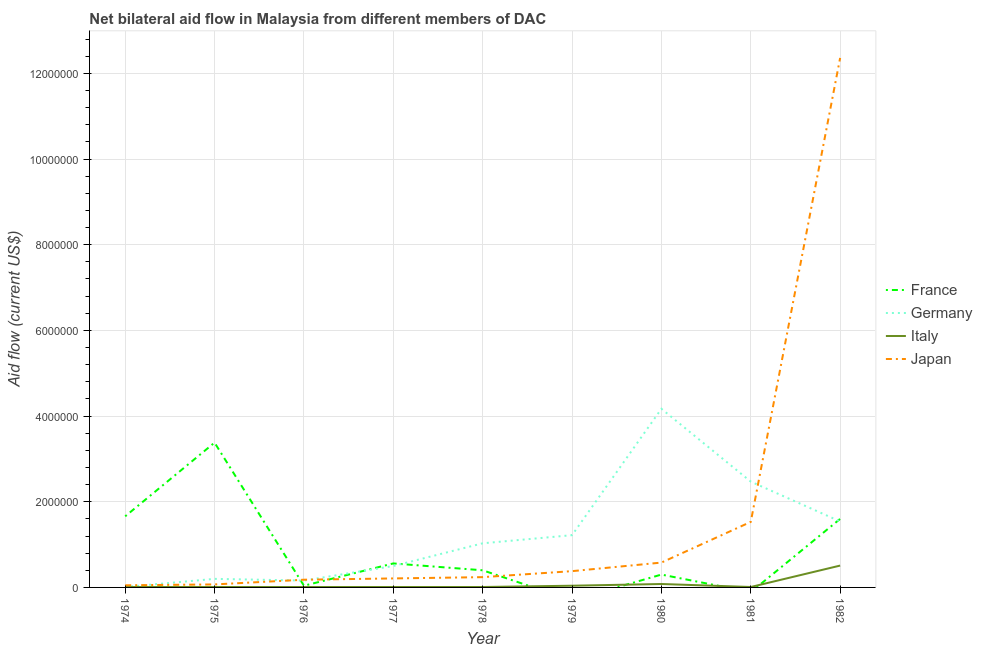How many different coloured lines are there?
Provide a succinct answer. 4. Is the number of lines equal to the number of legend labels?
Ensure brevity in your answer.  No. What is the amount of aid given by japan in 1982?
Provide a succinct answer. 1.24e+07. Across all years, what is the maximum amount of aid given by japan?
Ensure brevity in your answer.  1.24e+07. In which year was the amount of aid given by italy maximum?
Your response must be concise. 1982. What is the total amount of aid given by france in the graph?
Your answer should be compact. 7.94e+06. What is the difference between the amount of aid given by japan in 1976 and that in 1980?
Offer a terse response. -4.00e+05. What is the difference between the amount of aid given by italy in 1981 and the amount of aid given by japan in 1977?
Make the answer very short. -2.00e+05. What is the average amount of aid given by france per year?
Provide a short and direct response. 8.82e+05. In the year 1975, what is the difference between the amount of aid given by italy and amount of aid given by germany?
Provide a succinct answer. -1.90e+05. In how many years, is the amount of aid given by japan greater than 6400000 US$?
Your answer should be compact. 1. What is the ratio of the amount of aid given by italy in 1974 to that in 1979?
Offer a very short reply. 0.25. Is the difference between the amount of aid given by italy in 1976 and 1982 greater than the difference between the amount of aid given by japan in 1976 and 1982?
Ensure brevity in your answer.  Yes. What is the difference between the highest and the second highest amount of aid given by france?
Your answer should be compact. 1.72e+06. What is the difference between the highest and the lowest amount of aid given by italy?
Provide a succinct answer. 5.00e+05. Is the sum of the amount of aid given by italy in 1980 and 1981 greater than the maximum amount of aid given by japan across all years?
Offer a very short reply. No. Is it the case that in every year, the sum of the amount of aid given by japan and amount of aid given by france is greater than the sum of amount of aid given by italy and amount of aid given by germany?
Your answer should be very brief. No. Is it the case that in every year, the sum of the amount of aid given by france and amount of aid given by germany is greater than the amount of aid given by italy?
Your answer should be very brief. Yes. Does the amount of aid given by japan monotonically increase over the years?
Make the answer very short. Yes. Is the amount of aid given by france strictly less than the amount of aid given by italy over the years?
Your answer should be compact. No. How many lines are there?
Ensure brevity in your answer.  4. How many years are there in the graph?
Give a very brief answer. 9. What is the difference between two consecutive major ticks on the Y-axis?
Your answer should be compact. 2.00e+06. How many legend labels are there?
Offer a terse response. 4. How are the legend labels stacked?
Ensure brevity in your answer.  Vertical. What is the title of the graph?
Your answer should be compact. Net bilateral aid flow in Malaysia from different members of DAC. What is the label or title of the X-axis?
Provide a short and direct response. Year. What is the label or title of the Y-axis?
Provide a succinct answer. Aid flow (current US$). What is the Aid flow (current US$) in France in 1974?
Offer a terse response. 1.66e+06. What is the Aid flow (current US$) in Italy in 1974?
Keep it short and to the point. 10000. What is the Aid flow (current US$) in Japan in 1974?
Provide a short and direct response. 5.00e+04. What is the Aid flow (current US$) of France in 1975?
Your answer should be compact. 3.38e+06. What is the Aid flow (current US$) in Germany in 1975?
Keep it short and to the point. 2.00e+05. What is the Aid flow (current US$) of Japan in 1975?
Offer a very short reply. 7.00e+04. What is the Aid flow (current US$) in France in 1976?
Provide a succinct answer. 4.00e+04. What is the Aid flow (current US$) in Italy in 1976?
Your response must be concise. 10000. What is the Aid flow (current US$) in France in 1977?
Make the answer very short. 5.60e+05. What is the Aid flow (current US$) of Japan in 1977?
Give a very brief answer. 2.10e+05. What is the Aid flow (current US$) in Germany in 1978?
Make the answer very short. 1.03e+06. What is the Aid flow (current US$) of Germany in 1979?
Ensure brevity in your answer.  1.22e+06. What is the Aid flow (current US$) of Germany in 1980?
Offer a terse response. 4.17e+06. What is the Aid flow (current US$) of Italy in 1980?
Your response must be concise. 8.00e+04. What is the Aid flow (current US$) of Japan in 1980?
Offer a very short reply. 5.80e+05. What is the Aid flow (current US$) of Germany in 1981?
Keep it short and to the point. 2.47e+06. What is the Aid flow (current US$) of Italy in 1981?
Ensure brevity in your answer.  10000. What is the Aid flow (current US$) of Japan in 1981?
Make the answer very short. 1.53e+06. What is the Aid flow (current US$) of France in 1982?
Provide a succinct answer. 1.60e+06. What is the Aid flow (current US$) of Germany in 1982?
Offer a very short reply. 1.54e+06. What is the Aid flow (current US$) of Italy in 1982?
Your answer should be very brief. 5.10e+05. What is the Aid flow (current US$) of Japan in 1982?
Provide a succinct answer. 1.24e+07. Across all years, what is the maximum Aid flow (current US$) in France?
Your response must be concise. 3.38e+06. Across all years, what is the maximum Aid flow (current US$) in Germany?
Provide a short and direct response. 4.17e+06. Across all years, what is the maximum Aid flow (current US$) of Italy?
Your response must be concise. 5.10e+05. Across all years, what is the maximum Aid flow (current US$) of Japan?
Your answer should be compact. 1.24e+07. What is the total Aid flow (current US$) in France in the graph?
Provide a succinct answer. 7.94e+06. What is the total Aid flow (current US$) in Germany in the graph?
Make the answer very short. 1.13e+07. What is the total Aid flow (current US$) of Italy in the graph?
Offer a very short reply. 6.90e+05. What is the total Aid flow (current US$) of Japan in the graph?
Provide a short and direct response. 1.56e+07. What is the difference between the Aid flow (current US$) of France in 1974 and that in 1975?
Provide a short and direct response. -1.72e+06. What is the difference between the Aid flow (current US$) in Germany in 1974 and that in 1975?
Provide a succinct answer. -1.90e+05. What is the difference between the Aid flow (current US$) of Italy in 1974 and that in 1975?
Make the answer very short. 0. What is the difference between the Aid flow (current US$) in France in 1974 and that in 1976?
Your answer should be compact. 1.62e+06. What is the difference between the Aid flow (current US$) of Germany in 1974 and that in 1976?
Provide a succinct answer. -1.50e+05. What is the difference between the Aid flow (current US$) in France in 1974 and that in 1977?
Offer a terse response. 1.10e+06. What is the difference between the Aid flow (current US$) of Germany in 1974 and that in 1977?
Make the answer very short. -4.90e+05. What is the difference between the Aid flow (current US$) in Italy in 1974 and that in 1977?
Provide a short and direct response. 0. What is the difference between the Aid flow (current US$) in Japan in 1974 and that in 1977?
Make the answer very short. -1.60e+05. What is the difference between the Aid flow (current US$) in France in 1974 and that in 1978?
Your response must be concise. 1.26e+06. What is the difference between the Aid flow (current US$) in Germany in 1974 and that in 1978?
Your answer should be very brief. -1.02e+06. What is the difference between the Aid flow (current US$) of Japan in 1974 and that in 1978?
Provide a short and direct response. -1.90e+05. What is the difference between the Aid flow (current US$) of Germany in 1974 and that in 1979?
Provide a succinct answer. -1.21e+06. What is the difference between the Aid flow (current US$) in Italy in 1974 and that in 1979?
Keep it short and to the point. -3.00e+04. What is the difference between the Aid flow (current US$) of Japan in 1974 and that in 1979?
Provide a succinct answer. -3.30e+05. What is the difference between the Aid flow (current US$) of France in 1974 and that in 1980?
Offer a very short reply. 1.36e+06. What is the difference between the Aid flow (current US$) in Germany in 1974 and that in 1980?
Make the answer very short. -4.16e+06. What is the difference between the Aid flow (current US$) in Italy in 1974 and that in 1980?
Your response must be concise. -7.00e+04. What is the difference between the Aid flow (current US$) of Japan in 1974 and that in 1980?
Offer a very short reply. -5.30e+05. What is the difference between the Aid flow (current US$) of Germany in 1974 and that in 1981?
Make the answer very short. -2.46e+06. What is the difference between the Aid flow (current US$) of Italy in 1974 and that in 1981?
Your answer should be very brief. 0. What is the difference between the Aid flow (current US$) of Japan in 1974 and that in 1981?
Your response must be concise. -1.48e+06. What is the difference between the Aid flow (current US$) in France in 1974 and that in 1982?
Provide a succinct answer. 6.00e+04. What is the difference between the Aid flow (current US$) in Germany in 1974 and that in 1982?
Your response must be concise. -1.53e+06. What is the difference between the Aid flow (current US$) of Italy in 1974 and that in 1982?
Provide a succinct answer. -5.00e+05. What is the difference between the Aid flow (current US$) in Japan in 1974 and that in 1982?
Provide a short and direct response. -1.23e+07. What is the difference between the Aid flow (current US$) of France in 1975 and that in 1976?
Make the answer very short. 3.34e+06. What is the difference between the Aid flow (current US$) in Italy in 1975 and that in 1976?
Ensure brevity in your answer.  0. What is the difference between the Aid flow (current US$) of Japan in 1975 and that in 1976?
Make the answer very short. -1.10e+05. What is the difference between the Aid flow (current US$) of France in 1975 and that in 1977?
Your response must be concise. 2.82e+06. What is the difference between the Aid flow (current US$) in Germany in 1975 and that in 1977?
Provide a succinct answer. -3.00e+05. What is the difference between the Aid flow (current US$) of Italy in 1975 and that in 1977?
Make the answer very short. 0. What is the difference between the Aid flow (current US$) in France in 1975 and that in 1978?
Your response must be concise. 2.98e+06. What is the difference between the Aid flow (current US$) in Germany in 1975 and that in 1978?
Provide a succinct answer. -8.30e+05. What is the difference between the Aid flow (current US$) in Italy in 1975 and that in 1978?
Your response must be concise. 0. What is the difference between the Aid flow (current US$) of Germany in 1975 and that in 1979?
Your answer should be compact. -1.02e+06. What is the difference between the Aid flow (current US$) of Japan in 1975 and that in 1979?
Your answer should be very brief. -3.10e+05. What is the difference between the Aid flow (current US$) of France in 1975 and that in 1980?
Keep it short and to the point. 3.08e+06. What is the difference between the Aid flow (current US$) of Germany in 1975 and that in 1980?
Provide a succinct answer. -3.97e+06. What is the difference between the Aid flow (current US$) in Japan in 1975 and that in 1980?
Offer a terse response. -5.10e+05. What is the difference between the Aid flow (current US$) of Germany in 1975 and that in 1981?
Offer a very short reply. -2.27e+06. What is the difference between the Aid flow (current US$) in Italy in 1975 and that in 1981?
Provide a short and direct response. 0. What is the difference between the Aid flow (current US$) in Japan in 1975 and that in 1981?
Ensure brevity in your answer.  -1.46e+06. What is the difference between the Aid flow (current US$) of France in 1975 and that in 1982?
Give a very brief answer. 1.78e+06. What is the difference between the Aid flow (current US$) of Germany in 1975 and that in 1982?
Provide a short and direct response. -1.34e+06. What is the difference between the Aid flow (current US$) of Italy in 1975 and that in 1982?
Keep it short and to the point. -5.00e+05. What is the difference between the Aid flow (current US$) in Japan in 1975 and that in 1982?
Offer a terse response. -1.23e+07. What is the difference between the Aid flow (current US$) in France in 1976 and that in 1977?
Your response must be concise. -5.20e+05. What is the difference between the Aid flow (current US$) in Germany in 1976 and that in 1977?
Give a very brief answer. -3.40e+05. What is the difference between the Aid flow (current US$) of Italy in 1976 and that in 1977?
Provide a short and direct response. 0. What is the difference between the Aid flow (current US$) in France in 1976 and that in 1978?
Offer a terse response. -3.60e+05. What is the difference between the Aid flow (current US$) in Germany in 1976 and that in 1978?
Provide a succinct answer. -8.70e+05. What is the difference between the Aid flow (current US$) in Japan in 1976 and that in 1978?
Your answer should be compact. -6.00e+04. What is the difference between the Aid flow (current US$) of Germany in 1976 and that in 1979?
Keep it short and to the point. -1.06e+06. What is the difference between the Aid flow (current US$) in Italy in 1976 and that in 1979?
Your answer should be very brief. -3.00e+04. What is the difference between the Aid flow (current US$) of Japan in 1976 and that in 1979?
Your answer should be very brief. -2.00e+05. What is the difference between the Aid flow (current US$) in France in 1976 and that in 1980?
Your response must be concise. -2.60e+05. What is the difference between the Aid flow (current US$) in Germany in 1976 and that in 1980?
Give a very brief answer. -4.01e+06. What is the difference between the Aid flow (current US$) in Italy in 1976 and that in 1980?
Ensure brevity in your answer.  -7.00e+04. What is the difference between the Aid flow (current US$) of Japan in 1976 and that in 1980?
Keep it short and to the point. -4.00e+05. What is the difference between the Aid flow (current US$) of Germany in 1976 and that in 1981?
Offer a very short reply. -2.31e+06. What is the difference between the Aid flow (current US$) of Italy in 1976 and that in 1981?
Your response must be concise. 0. What is the difference between the Aid flow (current US$) of Japan in 1976 and that in 1981?
Offer a very short reply. -1.35e+06. What is the difference between the Aid flow (current US$) in France in 1976 and that in 1982?
Give a very brief answer. -1.56e+06. What is the difference between the Aid flow (current US$) in Germany in 1976 and that in 1982?
Ensure brevity in your answer.  -1.38e+06. What is the difference between the Aid flow (current US$) of Italy in 1976 and that in 1982?
Your response must be concise. -5.00e+05. What is the difference between the Aid flow (current US$) in Japan in 1976 and that in 1982?
Make the answer very short. -1.22e+07. What is the difference between the Aid flow (current US$) of Germany in 1977 and that in 1978?
Ensure brevity in your answer.  -5.30e+05. What is the difference between the Aid flow (current US$) in Germany in 1977 and that in 1979?
Your answer should be compact. -7.20e+05. What is the difference between the Aid flow (current US$) of Japan in 1977 and that in 1979?
Provide a short and direct response. -1.70e+05. What is the difference between the Aid flow (current US$) in France in 1977 and that in 1980?
Your answer should be very brief. 2.60e+05. What is the difference between the Aid flow (current US$) of Germany in 1977 and that in 1980?
Offer a very short reply. -3.67e+06. What is the difference between the Aid flow (current US$) in Japan in 1977 and that in 1980?
Keep it short and to the point. -3.70e+05. What is the difference between the Aid flow (current US$) in Germany in 1977 and that in 1981?
Offer a terse response. -1.97e+06. What is the difference between the Aid flow (current US$) in Japan in 1977 and that in 1981?
Give a very brief answer. -1.32e+06. What is the difference between the Aid flow (current US$) of France in 1977 and that in 1982?
Your answer should be compact. -1.04e+06. What is the difference between the Aid flow (current US$) of Germany in 1977 and that in 1982?
Offer a very short reply. -1.04e+06. What is the difference between the Aid flow (current US$) of Italy in 1977 and that in 1982?
Give a very brief answer. -5.00e+05. What is the difference between the Aid flow (current US$) in Japan in 1977 and that in 1982?
Give a very brief answer. -1.22e+07. What is the difference between the Aid flow (current US$) of Germany in 1978 and that in 1979?
Offer a very short reply. -1.90e+05. What is the difference between the Aid flow (current US$) of Japan in 1978 and that in 1979?
Offer a very short reply. -1.40e+05. What is the difference between the Aid flow (current US$) in France in 1978 and that in 1980?
Provide a short and direct response. 1.00e+05. What is the difference between the Aid flow (current US$) in Germany in 1978 and that in 1980?
Your response must be concise. -3.14e+06. What is the difference between the Aid flow (current US$) of Italy in 1978 and that in 1980?
Make the answer very short. -7.00e+04. What is the difference between the Aid flow (current US$) of Japan in 1978 and that in 1980?
Provide a short and direct response. -3.40e+05. What is the difference between the Aid flow (current US$) of Germany in 1978 and that in 1981?
Keep it short and to the point. -1.44e+06. What is the difference between the Aid flow (current US$) in Japan in 1978 and that in 1981?
Provide a succinct answer. -1.29e+06. What is the difference between the Aid flow (current US$) in France in 1978 and that in 1982?
Give a very brief answer. -1.20e+06. What is the difference between the Aid flow (current US$) of Germany in 1978 and that in 1982?
Give a very brief answer. -5.10e+05. What is the difference between the Aid flow (current US$) of Italy in 1978 and that in 1982?
Provide a succinct answer. -5.00e+05. What is the difference between the Aid flow (current US$) in Japan in 1978 and that in 1982?
Provide a succinct answer. -1.21e+07. What is the difference between the Aid flow (current US$) of Germany in 1979 and that in 1980?
Your answer should be compact. -2.95e+06. What is the difference between the Aid flow (current US$) of Italy in 1979 and that in 1980?
Ensure brevity in your answer.  -4.00e+04. What is the difference between the Aid flow (current US$) in Germany in 1979 and that in 1981?
Give a very brief answer. -1.25e+06. What is the difference between the Aid flow (current US$) in Japan in 1979 and that in 1981?
Offer a very short reply. -1.15e+06. What is the difference between the Aid flow (current US$) of Germany in 1979 and that in 1982?
Your response must be concise. -3.20e+05. What is the difference between the Aid flow (current US$) in Italy in 1979 and that in 1982?
Provide a succinct answer. -4.70e+05. What is the difference between the Aid flow (current US$) in Japan in 1979 and that in 1982?
Your response must be concise. -1.20e+07. What is the difference between the Aid flow (current US$) of Germany in 1980 and that in 1981?
Keep it short and to the point. 1.70e+06. What is the difference between the Aid flow (current US$) in Italy in 1980 and that in 1981?
Provide a short and direct response. 7.00e+04. What is the difference between the Aid flow (current US$) of Japan in 1980 and that in 1981?
Provide a short and direct response. -9.50e+05. What is the difference between the Aid flow (current US$) of France in 1980 and that in 1982?
Your answer should be very brief. -1.30e+06. What is the difference between the Aid flow (current US$) in Germany in 1980 and that in 1982?
Keep it short and to the point. 2.63e+06. What is the difference between the Aid flow (current US$) of Italy in 1980 and that in 1982?
Offer a very short reply. -4.30e+05. What is the difference between the Aid flow (current US$) of Japan in 1980 and that in 1982?
Make the answer very short. -1.18e+07. What is the difference between the Aid flow (current US$) in Germany in 1981 and that in 1982?
Ensure brevity in your answer.  9.30e+05. What is the difference between the Aid flow (current US$) in Italy in 1981 and that in 1982?
Provide a short and direct response. -5.00e+05. What is the difference between the Aid flow (current US$) in Japan in 1981 and that in 1982?
Provide a succinct answer. -1.08e+07. What is the difference between the Aid flow (current US$) of France in 1974 and the Aid flow (current US$) of Germany in 1975?
Your answer should be compact. 1.46e+06. What is the difference between the Aid flow (current US$) of France in 1974 and the Aid flow (current US$) of Italy in 1975?
Offer a very short reply. 1.65e+06. What is the difference between the Aid flow (current US$) in France in 1974 and the Aid flow (current US$) in Japan in 1975?
Your response must be concise. 1.59e+06. What is the difference between the Aid flow (current US$) in Germany in 1974 and the Aid flow (current US$) in Italy in 1975?
Make the answer very short. 0. What is the difference between the Aid flow (current US$) of Germany in 1974 and the Aid flow (current US$) of Japan in 1975?
Offer a very short reply. -6.00e+04. What is the difference between the Aid flow (current US$) in France in 1974 and the Aid flow (current US$) in Germany in 1976?
Your answer should be very brief. 1.50e+06. What is the difference between the Aid flow (current US$) of France in 1974 and the Aid flow (current US$) of Italy in 1976?
Offer a very short reply. 1.65e+06. What is the difference between the Aid flow (current US$) of France in 1974 and the Aid flow (current US$) of Japan in 1976?
Your answer should be very brief. 1.48e+06. What is the difference between the Aid flow (current US$) in Germany in 1974 and the Aid flow (current US$) in Italy in 1976?
Ensure brevity in your answer.  0. What is the difference between the Aid flow (current US$) in France in 1974 and the Aid flow (current US$) in Germany in 1977?
Give a very brief answer. 1.16e+06. What is the difference between the Aid flow (current US$) in France in 1974 and the Aid flow (current US$) in Italy in 1977?
Ensure brevity in your answer.  1.65e+06. What is the difference between the Aid flow (current US$) of France in 1974 and the Aid flow (current US$) of Japan in 1977?
Provide a succinct answer. 1.45e+06. What is the difference between the Aid flow (current US$) in Germany in 1974 and the Aid flow (current US$) in Japan in 1977?
Keep it short and to the point. -2.00e+05. What is the difference between the Aid flow (current US$) of Italy in 1974 and the Aid flow (current US$) of Japan in 1977?
Give a very brief answer. -2.00e+05. What is the difference between the Aid flow (current US$) in France in 1974 and the Aid flow (current US$) in Germany in 1978?
Offer a very short reply. 6.30e+05. What is the difference between the Aid flow (current US$) in France in 1974 and the Aid flow (current US$) in Italy in 1978?
Your response must be concise. 1.65e+06. What is the difference between the Aid flow (current US$) in France in 1974 and the Aid flow (current US$) in Japan in 1978?
Ensure brevity in your answer.  1.42e+06. What is the difference between the Aid flow (current US$) of Italy in 1974 and the Aid flow (current US$) of Japan in 1978?
Keep it short and to the point. -2.30e+05. What is the difference between the Aid flow (current US$) in France in 1974 and the Aid flow (current US$) in Italy in 1979?
Make the answer very short. 1.62e+06. What is the difference between the Aid flow (current US$) of France in 1974 and the Aid flow (current US$) of Japan in 1979?
Provide a succinct answer. 1.28e+06. What is the difference between the Aid flow (current US$) in Germany in 1974 and the Aid flow (current US$) in Italy in 1979?
Offer a terse response. -3.00e+04. What is the difference between the Aid flow (current US$) in Germany in 1974 and the Aid flow (current US$) in Japan in 1979?
Your response must be concise. -3.70e+05. What is the difference between the Aid flow (current US$) in Italy in 1974 and the Aid flow (current US$) in Japan in 1979?
Offer a terse response. -3.70e+05. What is the difference between the Aid flow (current US$) in France in 1974 and the Aid flow (current US$) in Germany in 1980?
Your answer should be very brief. -2.51e+06. What is the difference between the Aid flow (current US$) in France in 1974 and the Aid flow (current US$) in Italy in 1980?
Your answer should be very brief. 1.58e+06. What is the difference between the Aid flow (current US$) of France in 1974 and the Aid flow (current US$) of Japan in 1980?
Ensure brevity in your answer.  1.08e+06. What is the difference between the Aid flow (current US$) in Germany in 1974 and the Aid flow (current US$) in Japan in 1980?
Your answer should be compact. -5.70e+05. What is the difference between the Aid flow (current US$) of Italy in 1974 and the Aid flow (current US$) of Japan in 1980?
Ensure brevity in your answer.  -5.70e+05. What is the difference between the Aid flow (current US$) in France in 1974 and the Aid flow (current US$) in Germany in 1981?
Provide a succinct answer. -8.10e+05. What is the difference between the Aid flow (current US$) in France in 1974 and the Aid flow (current US$) in Italy in 1981?
Your answer should be very brief. 1.65e+06. What is the difference between the Aid flow (current US$) in Germany in 1974 and the Aid flow (current US$) in Italy in 1981?
Make the answer very short. 0. What is the difference between the Aid flow (current US$) in Germany in 1974 and the Aid flow (current US$) in Japan in 1981?
Keep it short and to the point. -1.52e+06. What is the difference between the Aid flow (current US$) in Italy in 1974 and the Aid flow (current US$) in Japan in 1981?
Offer a terse response. -1.52e+06. What is the difference between the Aid flow (current US$) of France in 1974 and the Aid flow (current US$) of Germany in 1982?
Make the answer very short. 1.20e+05. What is the difference between the Aid flow (current US$) in France in 1974 and the Aid flow (current US$) in Italy in 1982?
Offer a very short reply. 1.15e+06. What is the difference between the Aid flow (current US$) in France in 1974 and the Aid flow (current US$) in Japan in 1982?
Make the answer very short. -1.07e+07. What is the difference between the Aid flow (current US$) of Germany in 1974 and the Aid flow (current US$) of Italy in 1982?
Your response must be concise. -5.00e+05. What is the difference between the Aid flow (current US$) in Germany in 1974 and the Aid flow (current US$) in Japan in 1982?
Provide a succinct answer. -1.24e+07. What is the difference between the Aid flow (current US$) in Italy in 1974 and the Aid flow (current US$) in Japan in 1982?
Your answer should be very brief. -1.24e+07. What is the difference between the Aid flow (current US$) in France in 1975 and the Aid flow (current US$) in Germany in 1976?
Provide a short and direct response. 3.22e+06. What is the difference between the Aid flow (current US$) of France in 1975 and the Aid flow (current US$) of Italy in 1976?
Make the answer very short. 3.37e+06. What is the difference between the Aid flow (current US$) of France in 1975 and the Aid flow (current US$) of Japan in 1976?
Provide a succinct answer. 3.20e+06. What is the difference between the Aid flow (current US$) in Germany in 1975 and the Aid flow (current US$) in Italy in 1976?
Provide a succinct answer. 1.90e+05. What is the difference between the Aid flow (current US$) in Italy in 1975 and the Aid flow (current US$) in Japan in 1976?
Keep it short and to the point. -1.70e+05. What is the difference between the Aid flow (current US$) in France in 1975 and the Aid flow (current US$) in Germany in 1977?
Your response must be concise. 2.88e+06. What is the difference between the Aid flow (current US$) in France in 1975 and the Aid flow (current US$) in Italy in 1977?
Your response must be concise. 3.37e+06. What is the difference between the Aid flow (current US$) of France in 1975 and the Aid flow (current US$) of Japan in 1977?
Your answer should be compact. 3.17e+06. What is the difference between the Aid flow (current US$) of Germany in 1975 and the Aid flow (current US$) of Italy in 1977?
Ensure brevity in your answer.  1.90e+05. What is the difference between the Aid flow (current US$) of Germany in 1975 and the Aid flow (current US$) of Japan in 1977?
Your answer should be very brief. -10000. What is the difference between the Aid flow (current US$) in France in 1975 and the Aid flow (current US$) in Germany in 1978?
Keep it short and to the point. 2.35e+06. What is the difference between the Aid flow (current US$) in France in 1975 and the Aid flow (current US$) in Italy in 1978?
Offer a terse response. 3.37e+06. What is the difference between the Aid flow (current US$) in France in 1975 and the Aid flow (current US$) in Japan in 1978?
Provide a succinct answer. 3.14e+06. What is the difference between the Aid flow (current US$) of France in 1975 and the Aid flow (current US$) of Germany in 1979?
Your response must be concise. 2.16e+06. What is the difference between the Aid flow (current US$) in France in 1975 and the Aid flow (current US$) in Italy in 1979?
Your answer should be very brief. 3.34e+06. What is the difference between the Aid flow (current US$) of Italy in 1975 and the Aid flow (current US$) of Japan in 1979?
Give a very brief answer. -3.70e+05. What is the difference between the Aid flow (current US$) of France in 1975 and the Aid flow (current US$) of Germany in 1980?
Provide a succinct answer. -7.90e+05. What is the difference between the Aid flow (current US$) of France in 1975 and the Aid flow (current US$) of Italy in 1980?
Make the answer very short. 3.30e+06. What is the difference between the Aid flow (current US$) of France in 1975 and the Aid flow (current US$) of Japan in 1980?
Keep it short and to the point. 2.80e+06. What is the difference between the Aid flow (current US$) of Germany in 1975 and the Aid flow (current US$) of Italy in 1980?
Provide a short and direct response. 1.20e+05. What is the difference between the Aid flow (current US$) of Germany in 1975 and the Aid flow (current US$) of Japan in 1980?
Make the answer very short. -3.80e+05. What is the difference between the Aid flow (current US$) in Italy in 1975 and the Aid flow (current US$) in Japan in 1980?
Offer a terse response. -5.70e+05. What is the difference between the Aid flow (current US$) in France in 1975 and the Aid flow (current US$) in Germany in 1981?
Offer a terse response. 9.10e+05. What is the difference between the Aid flow (current US$) of France in 1975 and the Aid flow (current US$) of Italy in 1981?
Keep it short and to the point. 3.37e+06. What is the difference between the Aid flow (current US$) of France in 1975 and the Aid flow (current US$) of Japan in 1981?
Ensure brevity in your answer.  1.85e+06. What is the difference between the Aid flow (current US$) of Germany in 1975 and the Aid flow (current US$) of Italy in 1981?
Keep it short and to the point. 1.90e+05. What is the difference between the Aid flow (current US$) of Germany in 1975 and the Aid flow (current US$) of Japan in 1981?
Your answer should be compact. -1.33e+06. What is the difference between the Aid flow (current US$) in Italy in 1975 and the Aid flow (current US$) in Japan in 1981?
Your response must be concise. -1.52e+06. What is the difference between the Aid flow (current US$) in France in 1975 and the Aid flow (current US$) in Germany in 1982?
Provide a short and direct response. 1.84e+06. What is the difference between the Aid flow (current US$) in France in 1975 and the Aid flow (current US$) in Italy in 1982?
Offer a terse response. 2.87e+06. What is the difference between the Aid flow (current US$) in France in 1975 and the Aid flow (current US$) in Japan in 1982?
Ensure brevity in your answer.  -8.98e+06. What is the difference between the Aid flow (current US$) of Germany in 1975 and the Aid flow (current US$) of Italy in 1982?
Offer a terse response. -3.10e+05. What is the difference between the Aid flow (current US$) in Germany in 1975 and the Aid flow (current US$) in Japan in 1982?
Provide a succinct answer. -1.22e+07. What is the difference between the Aid flow (current US$) of Italy in 1975 and the Aid flow (current US$) of Japan in 1982?
Your answer should be compact. -1.24e+07. What is the difference between the Aid flow (current US$) in France in 1976 and the Aid flow (current US$) in Germany in 1977?
Keep it short and to the point. -4.60e+05. What is the difference between the Aid flow (current US$) in France in 1976 and the Aid flow (current US$) in Italy in 1977?
Your answer should be compact. 3.00e+04. What is the difference between the Aid flow (current US$) of Germany in 1976 and the Aid flow (current US$) of Japan in 1977?
Provide a short and direct response. -5.00e+04. What is the difference between the Aid flow (current US$) of France in 1976 and the Aid flow (current US$) of Germany in 1978?
Offer a very short reply. -9.90e+05. What is the difference between the Aid flow (current US$) of France in 1976 and the Aid flow (current US$) of Italy in 1978?
Your answer should be compact. 3.00e+04. What is the difference between the Aid flow (current US$) of Germany in 1976 and the Aid flow (current US$) of Italy in 1978?
Make the answer very short. 1.50e+05. What is the difference between the Aid flow (current US$) in France in 1976 and the Aid flow (current US$) in Germany in 1979?
Give a very brief answer. -1.18e+06. What is the difference between the Aid flow (current US$) of France in 1976 and the Aid flow (current US$) of Italy in 1979?
Provide a succinct answer. 0. What is the difference between the Aid flow (current US$) in Germany in 1976 and the Aid flow (current US$) in Japan in 1979?
Ensure brevity in your answer.  -2.20e+05. What is the difference between the Aid flow (current US$) in Italy in 1976 and the Aid flow (current US$) in Japan in 1979?
Ensure brevity in your answer.  -3.70e+05. What is the difference between the Aid flow (current US$) of France in 1976 and the Aid flow (current US$) of Germany in 1980?
Make the answer very short. -4.13e+06. What is the difference between the Aid flow (current US$) of France in 1976 and the Aid flow (current US$) of Japan in 1980?
Provide a short and direct response. -5.40e+05. What is the difference between the Aid flow (current US$) of Germany in 1976 and the Aid flow (current US$) of Italy in 1980?
Your answer should be very brief. 8.00e+04. What is the difference between the Aid flow (current US$) of Germany in 1976 and the Aid flow (current US$) of Japan in 1980?
Provide a short and direct response. -4.20e+05. What is the difference between the Aid flow (current US$) of Italy in 1976 and the Aid flow (current US$) of Japan in 1980?
Keep it short and to the point. -5.70e+05. What is the difference between the Aid flow (current US$) in France in 1976 and the Aid flow (current US$) in Germany in 1981?
Offer a very short reply. -2.43e+06. What is the difference between the Aid flow (current US$) in France in 1976 and the Aid flow (current US$) in Italy in 1981?
Make the answer very short. 3.00e+04. What is the difference between the Aid flow (current US$) of France in 1976 and the Aid flow (current US$) of Japan in 1981?
Your response must be concise. -1.49e+06. What is the difference between the Aid flow (current US$) in Germany in 1976 and the Aid flow (current US$) in Italy in 1981?
Keep it short and to the point. 1.50e+05. What is the difference between the Aid flow (current US$) of Germany in 1976 and the Aid flow (current US$) of Japan in 1981?
Your answer should be very brief. -1.37e+06. What is the difference between the Aid flow (current US$) of Italy in 1976 and the Aid flow (current US$) of Japan in 1981?
Your answer should be very brief. -1.52e+06. What is the difference between the Aid flow (current US$) of France in 1976 and the Aid flow (current US$) of Germany in 1982?
Keep it short and to the point. -1.50e+06. What is the difference between the Aid flow (current US$) of France in 1976 and the Aid flow (current US$) of Italy in 1982?
Ensure brevity in your answer.  -4.70e+05. What is the difference between the Aid flow (current US$) in France in 1976 and the Aid flow (current US$) in Japan in 1982?
Give a very brief answer. -1.23e+07. What is the difference between the Aid flow (current US$) of Germany in 1976 and the Aid flow (current US$) of Italy in 1982?
Provide a short and direct response. -3.50e+05. What is the difference between the Aid flow (current US$) of Germany in 1976 and the Aid flow (current US$) of Japan in 1982?
Offer a terse response. -1.22e+07. What is the difference between the Aid flow (current US$) in Italy in 1976 and the Aid flow (current US$) in Japan in 1982?
Give a very brief answer. -1.24e+07. What is the difference between the Aid flow (current US$) in France in 1977 and the Aid flow (current US$) in Germany in 1978?
Your answer should be compact. -4.70e+05. What is the difference between the Aid flow (current US$) in France in 1977 and the Aid flow (current US$) in Italy in 1978?
Your answer should be compact. 5.50e+05. What is the difference between the Aid flow (current US$) in France in 1977 and the Aid flow (current US$) in Japan in 1978?
Give a very brief answer. 3.20e+05. What is the difference between the Aid flow (current US$) of Germany in 1977 and the Aid flow (current US$) of Italy in 1978?
Offer a very short reply. 4.90e+05. What is the difference between the Aid flow (current US$) in Germany in 1977 and the Aid flow (current US$) in Japan in 1978?
Provide a short and direct response. 2.60e+05. What is the difference between the Aid flow (current US$) of France in 1977 and the Aid flow (current US$) of Germany in 1979?
Offer a terse response. -6.60e+05. What is the difference between the Aid flow (current US$) of France in 1977 and the Aid flow (current US$) of Italy in 1979?
Your answer should be very brief. 5.20e+05. What is the difference between the Aid flow (current US$) in Germany in 1977 and the Aid flow (current US$) in Italy in 1979?
Keep it short and to the point. 4.60e+05. What is the difference between the Aid flow (current US$) of Italy in 1977 and the Aid flow (current US$) of Japan in 1979?
Your answer should be very brief. -3.70e+05. What is the difference between the Aid flow (current US$) in France in 1977 and the Aid flow (current US$) in Germany in 1980?
Keep it short and to the point. -3.61e+06. What is the difference between the Aid flow (current US$) of Italy in 1977 and the Aid flow (current US$) of Japan in 1980?
Give a very brief answer. -5.70e+05. What is the difference between the Aid flow (current US$) in France in 1977 and the Aid flow (current US$) in Germany in 1981?
Offer a terse response. -1.91e+06. What is the difference between the Aid flow (current US$) in France in 1977 and the Aid flow (current US$) in Italy in 1981?
Ensure brevity in your answer.  5.50e+05. What is the difference between the Aid flow (current US$) in France in 1977 and the Aid flow (current US$) in Japan in 1981?
Provide a succinct answer. -9.70e+05. What is the difference between the Aid flow (current US$) in Germany in 1977 and the Aid flow (current US$) in Italy in 1981?
Provide a succinct answer. 4.90e+05. What is the difference between the Aid flow (current US$) of Germany in 1977 and the Aid flow (current US$) of Japan in 1981?
Your answer should be very brief. -1.03e+06. What is the difference between the Aid flow (current US$) in Italy in 1977 and the Aid flow (current US$) in Japan in 1981?
Your response must be concise. -1.52e+06. What is the difference between the Aid flow (current US$) in France in 1977 and the Aid flow (current US$) in Germany in 1982?
Ensure brevity in your answer.  -9.80e+05. What is the difference between the Aid flow (current US$) in France in 1977 and the Aid flow (current US$) in Japan in 1982?
Your response must be concise. -1.18e+07. What is the difference between the Aid flow (current US$) in Germany in 1977 and the Aid flow (current US$) in Italy in 1982?
Your response must be concise. -10000. What is the difference between the Aid flow (current US$) in Germany in 1977 and the Aid flow (current US$) in Japan in 1982?
Your answer should be very brief. -1.19e+07. What is the difference between the Aid flow (current US$) in Italy in 1977 and the Aid flow (current US$) in Japan in 1982?
Give a very brief answer. -1.24e+07. What is the difference between the Aid flow (current US$) in France in 1978 and the Aid flow (current US$) in Germany in 1979?
Ensure brevity in your answer.  -8.20e+05. What is the difference between the Aid flow (current US$) in France in 1978 and the Aid flow (current US$) in Japan in 1979?
Your answer should be compact. 2.00e+04. What is the difference between the Aid flow (current US$) of Germany in 1978 and the Aid flow (current US$) of Italy in 1979?
Give a very brief answer. 9.90e+05. What is the difference between the Aid flow (current US$) of Germany in 1978 and the Aid flow (current US$) of Japan in 1979?
Provide a succinct answer. 6.50e+05. What is the difference between the Aid flow (current US$) in Italy in 1978 and the Aid flow (current US$) in Japan in 1979?
Your response must be concise. -3.70e+05. What is the difference between the Aid flow (current US$) of France in 1978 and the Aid flow (current US$) of Germany in 1980?
Ensure brevity in your answer.  -3.77e+06. What is the difference between the Aid flow (current US$) of France in 1978 and the Aid flow (current US$) of Italy in 1980?
Provide a short and direct response. 3.20e+05. What is the difference between the Aid flow (current US$) in France in 1978 and the Aid flow (current US$) in Japan in 1980?
Give a very brief answer. -1.80e+05. What is the difference between the Aid flow (current US$) in Germany in 1978 and the Aid flow (current US$) in Italy in 1980?
Keep it short and to the point. 9.50e+05. What is the difference between the Aid flow (current US$) in Germany in 1978 and the Aid flow (current US$) in Japan in 1980?
Keep it short and to the point. 4.50e+05. What is the difference between the Aid flow (current US$) of Italy in 1978 and the Aid flow (current US$) of Japan in 1980?
Keep it short and to the point. -5.70e+05. What is the difference between the Aid flow (current US$) of France in 1978 and the Aid flow (current US$) of Germany in 1981?
Provide a succinct answer. -2.07e+06. What is the difference between the Aid flow (current US$) of France in 1978 and the Aid flow (current US$) of Japan in 1981?
Make the answer very short. -1.13e+06. What is the difference between the Aid flow (current US$) in Germany in 1978 and the Aid flow (current US$) in Italy in 1981?
Give a very brief answer. 1.02e+06. What is the difference between the Aid flow (current US$) in Germany in 1978 and the Aid flow (current US$) in Japan in 1981?
Offer a very short reply. -5.00e+05. What is the difference between the Aid flow (current US$) of Italy in 1978 and the Aid flow (current US$) of Japan in 1981?
Your response must be concise. -1.52e+06. What is the difference between the Aid flow (current US$) in France in 1978 and the Aid flow (current US$) in Germany in 1982?
Your response must be concise. -1.14e+06. What is the difference between the Aid flow (current US$) in France in 1978 and the Aid flow (current US$) in Japan in 1982?
Ensure brevity in your answer.  -1.20e+07. What is the difference between the Aid flow (current US$) of Germany in 1978 and the Aid flow (current US$) of Italy in 1982?
Give a very brief answer. 5.20e+05. What is the difference between the Aid flow (current US$) of Germany in 1978 and the Aid flow (current US$) of Japan in 1982?
Provide a short and direct response. -1.13e+07. What is the difference between the Aid flow (current US$) in Italy in 1978 and the Aid flow (current US$) in Japan in 1982?
Provide a short and direct response. -1.24e+07. What is the difference between the Aid flow (current US$) of Germany in 1979 and the Aid flow (current US$) of Italy in 1980?
Your response must be concise. 1.14e+06. What is the difference between the Aid flow (current US$) in Germany in 1979 and the Aid flow (current US$) in Japan in 1980?
Offer a very short reply. 6.40e+05. What is the difference between the Aid flow (current US$) in Italy in 1979 and the Aid flow (current US$) in Japan in 1980?
Keep it short and to the point. -5.40e+05. What is the difference between the Aid flow (current US$) in Germany in 1979 and the Aid flow (current US$) in Italy in 1981?
Offer a terse response. 1.21e+06. What is the difference between the Aid flow (current US$) in Germany in 1979 and the Aid flow (current US$) in Japan in 1981?
Provide a succinct answer. -3.10e+05. What is the difference between the Aid flow (current US$) of Italy in 1979 and the Aid flow (current US$) of Japan in 1981?
Offer a very short reply. -1.49e+06. What is the difference between the Aid flow (current US$) in Germany in 1979 and the Aid flow (current US$) in Italy in 1982?
Give a very brief answer. 7.10e+05. What is the difference between the Aid flow (current US$) of Germany in 1979 and the Aid flow (current US$) of Japan in 1982?
Offer a very short reply. -1.11e+07. What is the difference between the Aid flow (current US$) in Italy in 1979 and the Aid flow (current US$) in Japan in 1982?
Your answer should be compact. -1.23e+07. What is the difference between the Aid flow (current US$) in France in 1980 and the Aid flow (current US$) in Germany in 1981?
Your answer should be compact. -2.17e+06. What is the difference between the Aid flow (current US$) of France in 1980 and the Aid flow (current US$) of Japan in 1981?
Keep it short and to the point. -1.23e+06. What is the difference between the Aid flow (current US$) of Germany in 1980 and the Aid flow (current US$) of Italy in 1981?
Your answer should be compact. 4.16e+06. What is the difference between the Aid flow (current US$) of Germany in 1980 and the Aid flow (current US$) of Japan in 1981?
Provide a succinct answer. 2.64e+06. What is the difference between the Aid flow (current US$) of Italy in 1980 and the Aid flow (current US$) of Japan in 1981?
Your response must be concise. -1.45e+06. What is the difference between the Aid flow (current US$) in France in 1980 and the Aid flow (current US$) in Germany in 1982?
Keep it short and to the point. -1.24e+06. What is the difference between the Aid flow (current US$) in France in 1980 and the Aid flow (current US$) in Japan in 1982?
Offer a very short reply. -1.21e+07. What is the difference between the Aid flow (current US$) of Germany in 1980 and the Aid flow (current US$) of Italy in 1982?
Ensure brevity in your answer.  3.66e+06. What is the difference between the Aid flow (current US$) in Germany in 1980 and the Aid flow (current US$) in Japan in 1982?
Offer a very short reply. -8.19e+06. What is the difference between the Aid flow (current US$) of Italy in 1980 and the Aid flow (current US$) of Japan in 1982?
Ensure brevity in your answer.  -1.23e+07. What is the difference between the Aid flow (current US$) of Germany in 1981 and the Aid flow (current US$) of Italy in 1982?
Offer a terse response. 1.96e+06. What is the difference between the Aid flow (current US$) in Germany in 1981 and the Aid flow (current US$) in Japan in 1982?
Offer a very short reply. -9.89e+06. What is the difference between the Aid flow (current US$) in Italy in 1981 and the Aid flow (current US$) in Japan in 1982?
Offer a very short reply. -1.24e+07. What is the average Aid flow (current US$) in France per year?
Offer a very short reply. 8.82e+05. What is the average Aid flow (current US$) in Germany per year?
Ensure brevity in your answer.  1.26e+06. What is the average Aid flow (current US$) in Italy per year?
Give a very brief answer. 7.67e+04. What is the average Aid flow (current US$) of Japan per year?
Provide a succinct answer. 1.73e+06. In the year 1974, what is the difference between the Aid flow (current US$) in France and Aid flow (current US$) in Germany?
Your answer should be very brief. 1.65e+06. In the year 1974, what is the difference between the Aid flow (current US$) of France and Aid flow (current US$) of Italy?
Give a very brief answer. 1.65e+06. In the year 1974, what is the difference between the Aid flow (current US$) of France and Aid flow (current US$) of Japan?
Your response must be concise. 1.61e+06. In the year 1974, what is the difference between the Aid flow (current US$) of Germany and Aid flow (current US$) of Italy?
Provide a short and direct response. 0. In the year 1974, what is the difference between the Aid flow (current US$) of Germany and Aid flow (current US$) of Japan?
Your answer should be very brief. -4.00e+04. In the year 1975, what is the difference between the Aid flow (current US$) of France and Aid flow (current US$) of Germany?
Make the answer very short. 3.18e+06. In the year 1975, what is the difference between the Aid flow (current US$) in France and Aid flow (current US$) in Italy?
Your answer should be very brief. 3.37e+06. In the year 1975, what is the difference between the Aid flow (current US$) of France and Aid flow (current US$) of Japan?
Provide a short and direct response. 3.31e+06. In the year 1975, what is the difference between the Aid flow (current US$) in Germany and Aid flow (current US$) in Italy?
Your response must be concise. 1.90e+05. In the year 1976, what is the difference between the Aid flow (current US$) of France and Aid flow (current US$) of Germany?
Your response must be concise. -1.20e+05. In the year 1976, what is the difference between the Aid flow (current US$) in Germany and Aid flow (current US$) in Italy?
Offer a terse response. 1.50e+05. In the year 1976, what is the difference between the Aid flow (current US$) in Germany and Aid flow (current US$) in Japan?
Provide a succinct answer. -2.00e+04. In the year 1976, what is the difference between the Aid flow (current US$) of Italy and Aid flow (current US$) of Japan?
Offer a very short reply. -1.70e+05. In the year 1977, what is the difference between the Aid flow (current US$) of France and Aid flow (current US$) of Germany?
Make the answer very short. 6.00e+04. In the year 1977, what is the difference between the Aid flow (current US$) of France and Aid flow (current US$) of Japan?
Give a very brief answer. 3.50e+05. In the year 1977, what is the difference between the Aid flow (current US$) of Germany and Aid flow (current US$) of Japan?
Keep it short and to the point. 2.90e+05. In the year 1977, what is the difference between the Aid flow (current US$) in Italy and Aid flow (current US$) in Japan?
Offer a very short reply. -2.00e+05. In the year 1978, what is the difference between the Aid flow (current US$) of France and Aid flow (current US$) of Germany?
Offer a very short reply. -6.30e+05. In the year 1978, what is the difference between the Aid flow (current US$) in France and Aid flow (current US$) in Italy?
Offer a very short reply. 3.90e+05. In the year 1978, what is the difference between the Aid flow (current US$) of Germany and Aid flow (current US$) of Italy?
Provide a short and direct response. 1.02e+06. In the year 1978, what is the difference between the Aid flow (current US$) of Germany and Aid flow (current US$) of Japan?
Ensure brevity in your answer.  7.90e+05. In the year 1979, what is the difference between the Aid flow (current US$) of Germany and Aid flow (current US$) of Italy?
Keep it short and to the point. 1.18e+06. In the year 1979, what is the difference between the Aid flow (current US$) of Germany and Aid flow (current US$) of Japan?
Ensure brevity in your answer.  8.40e+05. In the year 1979, what is the difference between the Aid flow (current US$) in Italy and Aid flow (current US$) in Japan?
Ensure brevity in your answer.  -3.40e+05. In the year 1980, what is the difference between the Aid flow (current US$) of France and Aid flow (current US$) of Germany?
Your answer should be compact. -3.87e+06. In the year 1980, what is the difference between the Aid flow (current US$) in France and Aid flow (current US$) in Italy?
Ensure brevity in your answer.  2.20e+05. In the year 1980, what is the difference between the Aid flow (current US$) in France and Aid flow (current US$) in Japan?
Ensure brevity in your answer.  -2.80e+05. In the year 1980, what is the difference between the Aid flow (current US$) in Germany and Aid flow (current US$) in Italy?
Give a very brief answer. 4.09e+06. In the year 1980, what is the difference between the Aid flow (current US$) in Germany and Aid flow (current US$) in Japan?
Ensure brevity in your answer.  3.59e+06. In the year 1980, what is the difference between the Aid flow (current US$) in Italy and Aid flow (current US$) in Japan?
Provide a short and direct response. -5.00e+05. In the year 1981, what is the difference between the Aid flow (current US$) of Germany and Aid flow (current US$) of Italy?
Ensure brevity in your answer.  2.46e+06. In the year 1981, what is the difference between the Aid flow (current US$) of Germany and Aid flow (current US$) of Japan?
Your answer should be compact. 9.40e+05. In the year 1981, what is the difference between the Aid flow (current US$) of Italy and Aid flow (current US$) of Japan?
Offer a very short reply. -1.52e+06. In the year 1982, what is the difference between the Aid flow (current US$) in France and Aid flow (current US$) in Germany?
Your answer should be very brief. 6.00e+04. In the year 1982, what is the difference between the Aid flow (current US$) of France and Aid flow (current US$) of Italy?
Provide a succinct answer. 1.09e+06. In the year 1982, what is the difference between the Aid flow (current US$) in France and Aid flow (current US$) in Japan?
Your answer should be very brief. -1.08e+07. In the year 1982, what is the difference between the Aid flow (current US$) in Germany and Aid flow (current US$) in Italy?
Your response must be concise. 1.03e+06. In the year 1982, what is the difference between the Aid flow (current US$) of Germany and Aid flow (current US$) of Japan?
Your answer should be very brief. -1.08e+07. In the year 1982, what is the difference between the Aid flow (current US$) in Italy and Aid flow (current US$) in Japan?
Your response must be concise. -1.18e+07. What is the ratio of the Aid flow (current US$) of France in 1974 to that in 1975?
Provide a succinct answer. 0.49. What is the ratio of the Aid flow (current US$) of Japan in 1974 to that in 1975?
Make the answer very short. 0.71. What is the ratio of the Aid flow (current US$) in France in 1974 to that in 1976?
Your answer should be very brief. 41.5. What is the ratio of the Aid flow (current US$) of Germany in 1974 to that in 1976?
Your response must be concise. 0.06. What is the ratio of the Aid flow (current US$) in Japan in 1974 to that in 1976?
Your response must be concise. 0.28. What is the ratio of the Aid flow (current US$) of France in 1974 to that in 1977?
Make the answer very short. 2.96. What is the ratio of the Aid flow (current US$) of Italy in 1974 to that in 1977?
Your answer should be very brief. 1. What is the ratio of the Aid flow (current US$) in Japan in 1974 to that in 1977?
Keep it short and to the point. 0.24. What is the ratio of the Aid flow (current US$) in France in 1974 to that in 1978?
Provide a succinct answer. 4.15. What is the ratio of the Aid flow (current US$) of Germany in 1974 to that in 1978?
Make the answer very short. 0.01. What is the ratio of the Aid flow (current US$) in Italy in 1974 to that in 1978?
Provide a succinct answer. 1. What is the ratio of the Aid flow (current US$) of Japan in 1974 to that in 1978?
Offer a very short reply. 0.21. What is the ratio of the Aid flow (current US$) in Germany in 1974 to that in 1979?
Give a very brief answer. 0.01. What is the ratio of the Aid flow (current US$) of Japan in 1974 to that in 1979?
Your response must be concise. 0.13. What is the ratio of the Aid flow (current US$) in France in 1974 to that in 1980?
Give a very brief answer. 5.53. What is the ratio of the Aid flow (current US$) of Germany in 1974 to that in 1980?
Make the answer very short. 0. What is the ratio of the Aid flow (current US$) in Italy in 1974 to that in 1980?
Make the answer very short. 0.12. What is the ratio of the Aid flow (current US$) in Japan in 1974 to that in 1980?
Keep it short and to the point. 0.09. What is the ratio of the Aid flow (current US$) of Germany in 1974 to that in 1981?
Provide a succinct answer. 0. What is the ratio of the Aid flow (current US$) in Japan in 1974 to that in 1981?
Offer a very short reply. 0.03. What is the ratio of the Aid flow (current US$) in France in 1974 to that in 1982?
Ensure brevity in your answer.  1.04. What is the ratio of the Aid flow (current US$) of Germany in 1974 to that in 1982?
Your answer should be very brief. 0.01. What is the ratio of the Aid flow (current US$) in Italy in 1974 to that in 1982?
Offer a very short reply. 0.02. What is the ratio of the Aid flow (current US$) in Japan in 1974 to that in 1982?
Provide a succinct answer. 0. What is the ratio of the Aid flow (current US$) of France in 1975 to that in 1976?
Keep it short and to the point. 84.5. What is the ratio of the Aid flow (current US$) in Japan in 1975 to that in 1976?
Offer a terse response. 0.39. What is the ratio of the Aid flow (current US$) of France in 1975 to that in 1977?
Your response must be concise. 6.04. What is the ratio of the Aid flow (current US$) of Italy in 1975 to that in 1977?
Offer a very short reply. 1. What is the ratio of the Aid flow (current US$) of Japan in 1975 to that in 1977?
Offer a very short reply. 0.33. What is the ratio of the Aid flow (current US$) in France in 1975 to that in 1978?
Your answer should be very brief. 8.45. What is the ratio of the Aid flow (current US$) in Germany in 1975 to that in 1978?
Make the answer very short. 0.19. What is the ratio of the Aid flow (current US$) in Japan in 1975 to that in 1978?
Your answer should be very brief. 0.29. What is the ratio of the Aid flow (current US$) in Germany in 1975 to that in 1979?
Your answer should be compact. 0.16. What is the ratio of the Aid flow (current US$) in Italy in 1975 to that in 1979?
Your answer should be very brief. 0.25. What is the ratio of the Aid flow (current US$) in Japan in 1975 to that in 1979?
Your response must be concise. 0.18. What is the ratio of the Aid flow (current US$) of France in 1975 to that in 1980?
Your response must be concise. 11.27. What is the ratio of the Aid flow (current US$) in Germany in 1975 to that in 1980?
Keep it short and to the point. 0.05. What is the ratio of the Aid flow (current US$) of Japan in 1975 to that in 1980?
Keep it short and to the point. 0.12. What is the ratio of the Aid flow (current US$) in Germany in 1975 to that in 1981?
Provide a short and direct response. 0.08. What is the ratio of the Aid flow (current US$) in Japan in 1975 to that in 1981?
Your answer should be compact. 0.05. What is the ratio of the Aid flow (current US$) of France in 1975 to that in 1982?
Ensure brevity in your answer.  2.11. What is the ratio of the Aid flow (current US$) in Germany in 1975 to that in 1982?
Your response must be concise. 0.13. What is the ratio of the Aid flow (current US$) of Italy in 1975 to that in 1982?
Provide a succinct answer. 0.02. What is the ratio of the Aid flow (current US$) in Japan in 1975 to that in 1982?
Keep it short and to the point. 0.01. What is the ratio of the Aid flow (current US$) of France in 1976 to that in 1977?
Provide a succinct answer. 0.07. What is the ratio of the Aid flow (current US$) of Germany in 1976 to that in 1977?
Make the answer very short. 0.32. What is the ratio of the Aid flow (current US$) of Japan in 1976 to that in 1977?
Your answer should be very brief. 0.86. What is the ratio of the Aid flow (current US$) of Germany in 1976 to that in 1978?
Give a very brief answer. 0.16. What is the ratio of the Aid flow (current US$) in Japan in 1976 to that in 1978?
Ensure brevity in your answer.  0.75. What is the ratio of the Aid flow (current US$) of Germany in 1976 to that in 1979?
Offer a terse response. 0.13. What is the ratio of the Aid flow (current US$) of Italy in 1976 to that in 1979?
Your answer should be compact. 0.25. What is the ratio of the Aid flow (current US$) of Japan in 1976 to that in 1979?
Your response must be concise. 0.47. What is the ratio of the Aid flow (current US$) of France in 1976 to that in 1980?
Offer a terse response. 0.13. What is the ratio of the Aid flow (current US$) of Germany in 1976 to that in 1980?
Your response must be concise. 0.04. What is the ratio of the Aid flow (current US$) in Japan in 1976 to that in 1980?
Make the answer very short. 0.31. What is the ratio of the Aid flow (current US$) of Germany in 1976 to that in 1981?
Offer a very short reply. 0.06. What is the ratio of the Aid flow (current US$) in Japan in 1976 to that in 1981?
Give a very brief answer. 0.12. What is the ratio of the Aid flow (current US$) in France in 1976 to that in 1982?
Your answer should be very brief. 0.03. What is the ratio of the Aid flow (current US$) of Germany in 1976 to that in 1982?
Your answer should be very brief. 0.1. What is the ratio of the Aid flow (current US$) of Italy in 1976 to that in 1982?
Your response must be concise. 0.02. What is the ratio of the Aid flow (current US$) of Japan in 1976 to that in 1982?
Provide a short and direct response. 0.01. What is the ratio of the Aid flow (current US$) of Germany in 1977 to that in 1978?
Keep it short and to the point. 0.49. What is the ratio of the Aid flow (current US$) in Japan in 1977 to that in 1978?
Keep it short and to the point. 0.88. What is the ratio of the Aid flow (current US$) in Germany in 1977 to that in 1979?
Offer a very short reply. 0.41. What is the ratio of the Aid flow (current US$) of Japan in 1977 to that in 1979?
Your response must be concise. 0.55. What is the ratio of the Aid flow (current US$) in France in 1977 to that in 1980?
Your answer should be compact. 1.87. What is the ratio of the Aid flow (current US$) in Germany in 1977 to that in 1980?
Offer a very short reply. 0.12. What is the ratio of the Aid flow (current US$) in Italy in 1977 to that in 1980?
Your response must be concise. 0.12. What is the ratio of the Aid flow (current US$) in Japan in 1977 to that in 1980?
Ensure brevity in your answer.  0.36. What is the ratio of the Aid flow (current US$) of Germany in 1977 to that in 1981?
Your answer should be very brief. 0.2. What is the ratio of the Aid flow (current US$) in Japan in 1977 to that in 1981?
Keep it short and to the point. 0.14. What is the ratio of the Aid flow (current US$) in France in 1977 to that in 1982?
Your response must be concise. 0.35. What is the ratio of the Aid flow (current US$) in Germany in 1977 to that in 1982?
Ensure brevity in your answer.  0.32. What is the ratio of the Aid flow (current US$) in Italy in 1977 to that in 1982?
Your answer should be compact. 0.02. What is the ratio of the Aid flow (current US$) of Japan in 1977 to that in 1982?
Your response must be concise. 0.02. What is the ratio of the Aid flow (current US$) in Germany in 1978 to that in 1979?
Make the answer very short. 0.84. What is the ratio of the Aid flow (current US$) in Japan in 1978 to that in 1979?
Offer a very short reply. 0.63. What is the ratio of the Aid flow (current US$) of France in 1978 to that in 1980?
Offer a terse response. 1.33. What is the ratio of the Aid flow (current US$) of Germany in 1978 to that in 1980?
Your answer should be very brief. 0.25. What is the ratio of the Aid flow (current US$) in Japan in 1978 to that in 1980?
Give a very brief answer. 0.41. What is the ratio of the Aid flow (current US$) in Germany in 1978 to that in 1981?
Offer a very short reply. 0.42. What is the ratio of the Aid flow (current US$) of Italy in 1978 to that in 1981?
Your response must be concise. 1. What is the ratio of the Aid flow (current US$) in Japan in 1978 to that in 1981?
Make the answer very short. 0.16. What is the ratio of the Aid flow (current US$) in Germany in 1978 to that in 1982?
Your response must be concise. 0.67. What is the ratio of the Aid flow (current US$) of Italy in 1978 to that in 1982?
Your response must be concise. 0.02. What is the ratio of the Aid flow (current US$) in Japan in 1978 to that in 1982?
Keep it short and to the point. 0.02. What is the ratio of the Aid flow (current US$) in Germany in 1979 to that in 1980?
Make the answer very short. 0.29. What is the ratio of the Aid flow (current US$) in Italy in 1979 to that in 1980?
Your response must be concise. 0.5. What is the ratio of the Aid flow (current US$) of Japan in 1979 to that in 1980?
Give a very brief answer. 0.66. What is the ratio of the Aid flow (current US$) in Germany in 1979 to that in 1981?
Your answer should be very brief. 0.49. What is the ratio of the Aid flow (current US$) of Italy in 1979 to that in 1981?
Offer a very short reply. 4. What is the ratio of the Aid flow (current US$) of Japan in 1979 to that in 1981?
Your answer should be very brief. 0.25. What is the ratio of the Aid flow (current US$) in Germany in 1979 to that in 1982?
Offer a terse response. 0.79. What is the ratio of the Aid flow (current US$) in Italy in 1979 to that in 1982?
Offer a terse response. 0.08. What is the ratio of the Aid flow (current US$) in Japan in 1979 to that in 1982?
Offer a very short reply. 0.03. What is the ratio of the Aid flow (current US$) of Germany in 1980 to that in 1981?
Provide a succinct answer. 1.69. What is the ratio of the Aid flow (current US$) of Japan in 1980 to that in 1981?
Give a very brief answer. 0.38. What is the ratio of the Aid flow (current US$) in France in 1980 to that in 1982?
Make the answer very short. 0.19. What is the ratio of the Aid flow (current US$) in Germany in 1980 to that in 1982?
Your response must be concise. 2.71. What is the ratio of the Aid flow (current US$) in Italy in 1980 to that in 1982?
Provide a succinct answer. 0.16. What is the ratio of the Aid flow (current US$) in Japan in 1980 to that in 1982?
Provide a succinct answer. 0.05. What is the ratio of the Aid flow (current US$) in Germany in 1981 to that in 1982?
Give a very brief answer. 1.6. What is the ratio of the Aid flow (current US$) of Italy in 1981 to that in 1982?
Make the answer very short. 0.02. What is the ratio of the Aid flow (current US$) of Japan in 1981 to that in 1982?
Provide a succinct answer. 0.12. What is the difference between the highest and the second highest Aid flow (current US$) in France?
Keep it short and to the point. 1.72e+06. What is the difference between the highest and the second highest Aid flow (current US$) in Germany?
Offer a terse response. 1.70e+06. What is the difference between the highest and the second highest Aid flow (current US$) in Japan?
Offer a very short reply. 1.08e+07. What is the difference between the highest and the lowest Aid flow (current US$) in France?
Your answer should be very brief. 3.38e+06. What is the difference between the highest and the lowest Aid flow (current US$) of Germany?
Offer a terse response. 4.16e+06. What is the difference between the highest and the lowest Aid flow (current US$) of Italy?
Provide a short and direct response. 5.00e+05. What is the difference between the highest and the lowest Aid flow (current US$) in Japan?
Offer a terse response. 1.23e+07. 